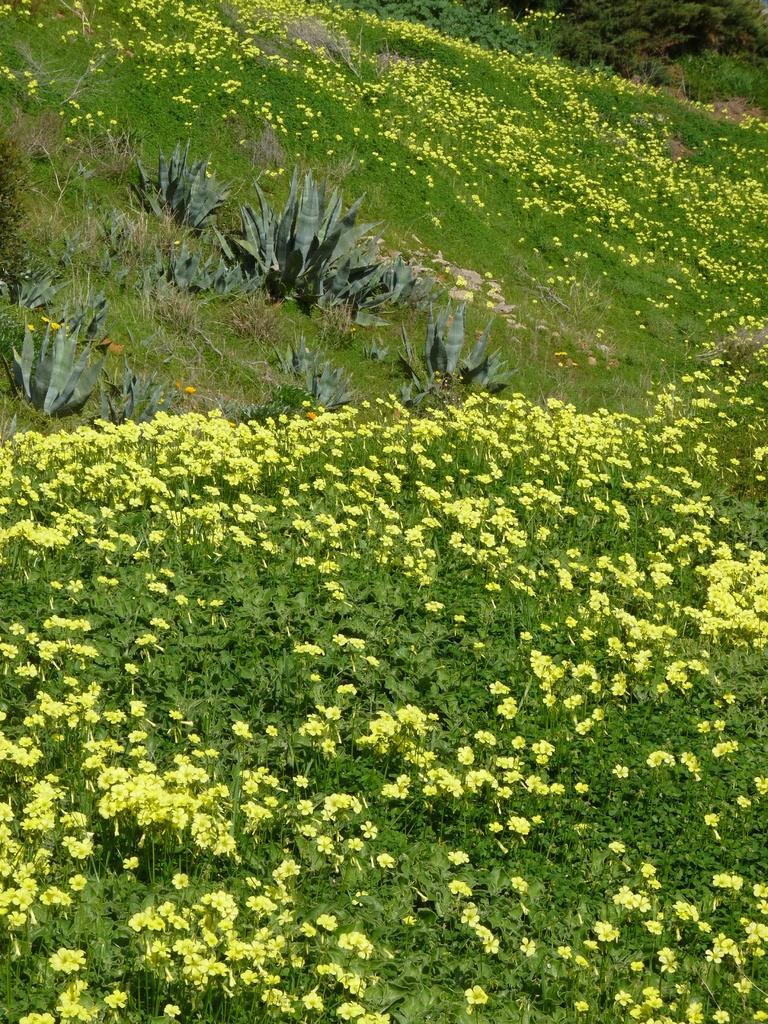How would you summarize this image in a sentence or two? In the picture I can see so many flowers to the plants and some grass. 